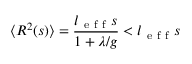<formula> <loc_0><loc_0><loc_500><loc_500>\langle R ^ { 2 } ( s ) \rangle = \frac { l _ { e f f } s } { 1 + \lambda / g } < l _ { e f f } s</formula> 